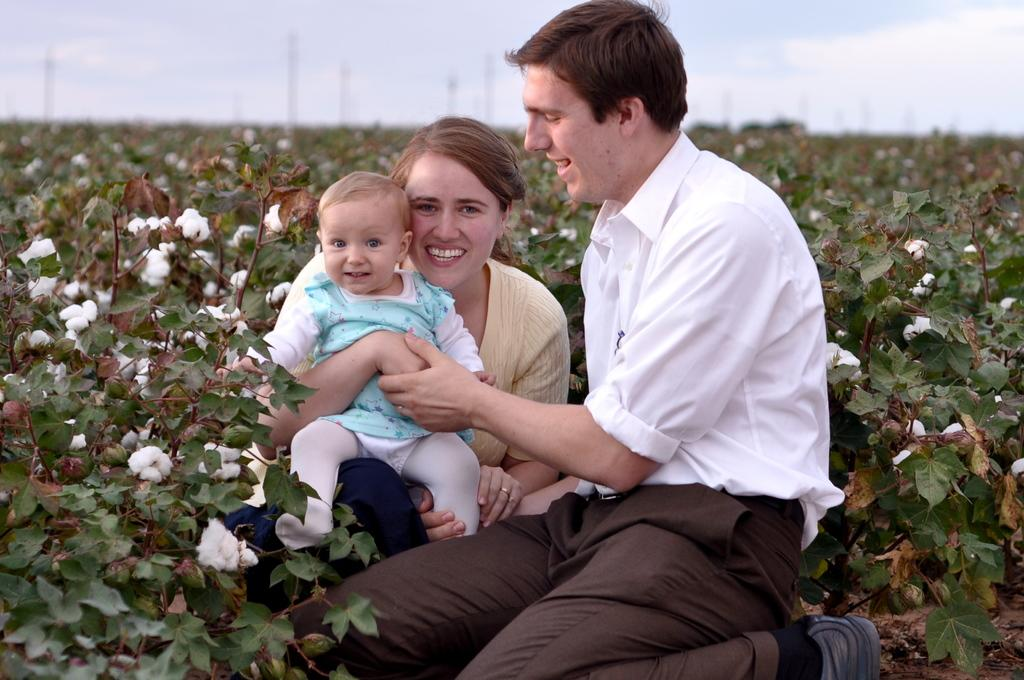How many people are present in the image? There are two people, a man and a woman, present in the image. What is the woman holding in the image? The woman is holding a baby in the image. What can be seen growing near the man and woman? There are cotton plants near the man and woman. What type of lunch is the man eating in the image? There is no lunch present in the image; the man is not eating anything. 